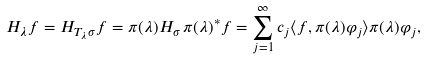<formula> <loc_0><loc_0><loc_500><loc_500>H _ { \lambda } f = H _ { T _ { \lambda } \sigma } f = \pi ( \lambda ) H _ { \sigma } \, \pi ( \lambda ) ^ { \ast } f = \sum _ { j = 1 } ^ { \infty } c _ { j } \langle f , \pi ( \lambda ) \varphi _ { j } \rangle \pi ( \lambda ) \varphi _ { j } ,</formula> 